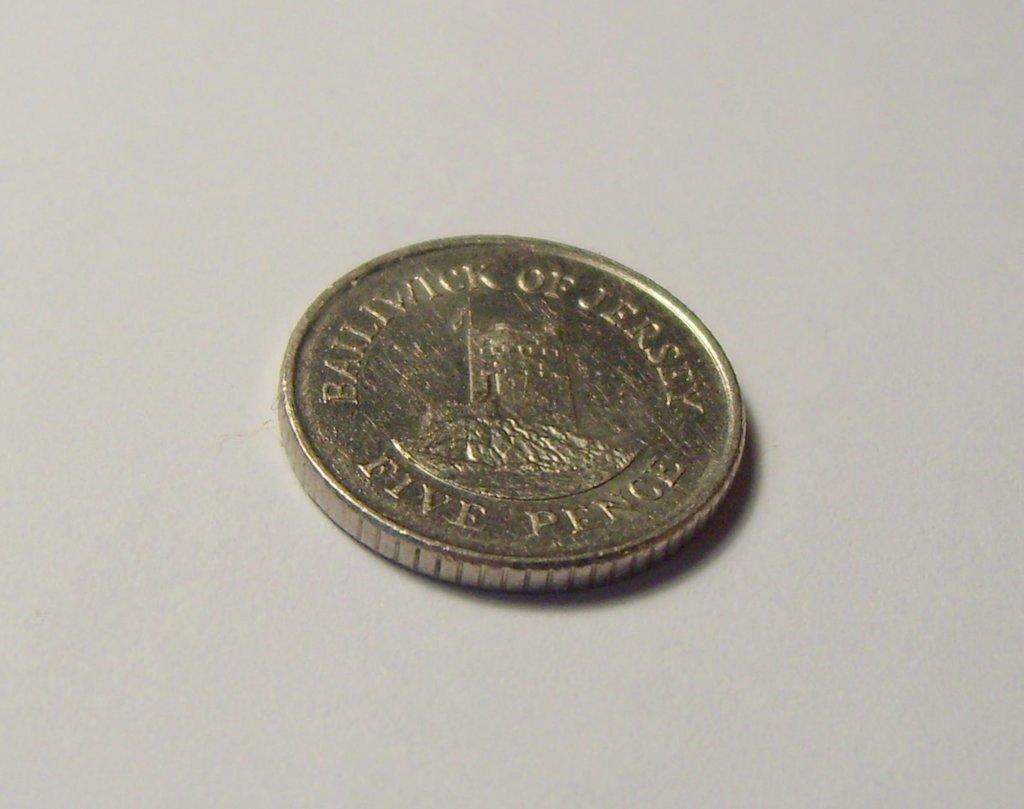<image>
Relay a brief, clear account of the picture shown. A silver colored five pence coin with Bailiwick of Jersey written around the perimeter. 